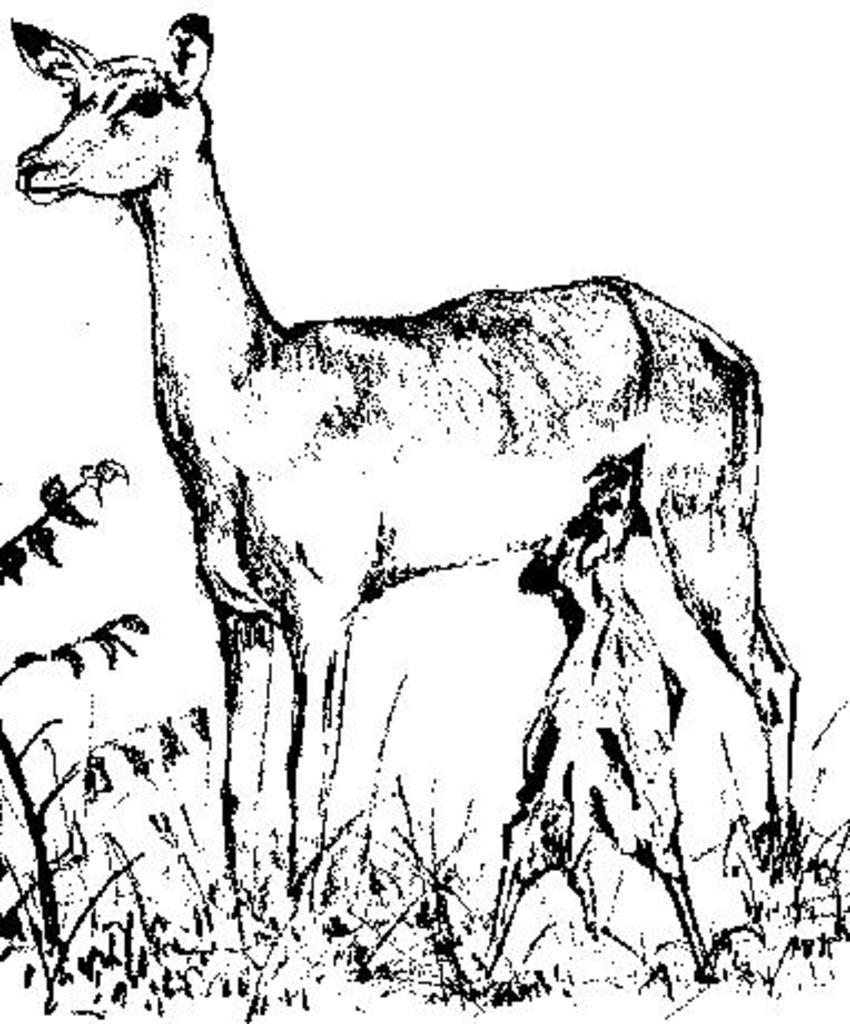What animal can be seen in the image? There is a deer in the image. What is the deer doing in the image? The deer is feeding a calf. Where does the scene take place? The scene takes place on a grassland. Can you see the deer and the calf fighting in the image? No, there is no fighting depicted in the image; the deer is feeding a calf. 